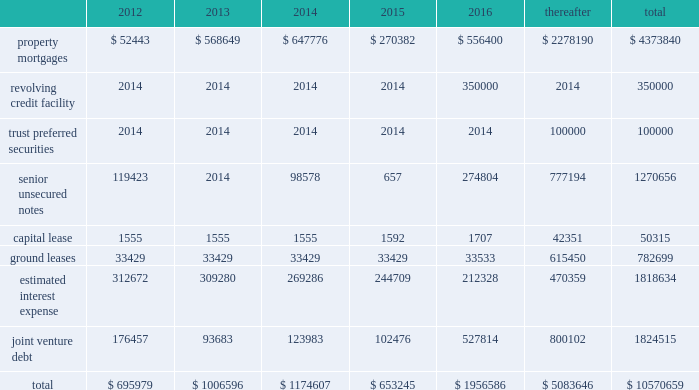56 / 57 management 2019s discussion and analysis of financial condition and results of operations junior subordinate deferrable interest debentures in june 2005 , we issued $ 100.0 a0million of trust preferred securities , which are reflected on the balance sheet as junior subordinate deferrable interest debentures .
The proceeds were used to repay our revolving credit facility .
The $ 100.0 a0million of junior subordi- nate deferrable interest debentures have a 30-year term ending july 2035 .
They bear interest at a fixed rate of 5.61% ( 5.61 % ) for the first 10 years ending july 2015 .
Thereafter , the rate will float at three month libor plus 1.25% ( 1.25 % ) .
The securities are redeemable at par .
Restrictive covenants the terms of the 2011 revolving credit facility and certain of our senior unsecured notes include certain restrictions and covenants which may limit , among other things , our ability to pay dividends ( as discussed below ) , make certain types of investments , incur additional indebtedness , incur liens and enter into negative pledge agreements and the disposition of assets , and which require compliance with financial ratios including our minimum tangible net worth , a maximum ratio of total indebtedness to total asset value , a minimum ratio of ebitda to fixed charges and a maximum ratio of unsecured indebtedness to unencumbered asset value .
The dividend restriction referred to above provides that we will not during any time when we are in default , make distributions with respect to common stock or other equity interests , except to enable us to continue to qualify as a reit for federal income tax purposes .
As of december a031 , 2011 and 2010 , we were in compli- ance with all such covenants .
Market rate risk we are exposed to changes in interest rates primarily from our floating rate borrowing arrangements .
We use interest rate deriv- ative instruments to manage exposure to interest rate changes .
A a0hypothetical 100 a0basis point increase in interest rates along the entire interest rate curve for 2011 and 2010 , would increase our annual interest cost by approximately $ 12.3 a0million and $ 11.0 a0mil- lion and would increase our share of joint venture annual interest cost by approximately $ 4.8 a0million and $ 6.7 a0million , respectively .
We recognize all derivatives on the balance sheet at fair value .
Derivatives that are not hedges must be adjusted to fair value through income .
If a derivative is a hedge , depending on the nature of the hedge , changes in the fair value of the derivative will either be offset against the change in fair value of the hedged asset , liability , or firm commitment through earnings , or recognized in other comprehensive income until the hedged item is recognized in earnings .
The ineffective portion of a derivative 2019s change in fair value is recognized immediately in earnings .
Approximately $ 4.8 a0billion of our long- term debt bore interest a0at fixed rates , and therefore the fair value of these instru- ments is affected by changes in the market interest rates .
The interest rate on our variable rate debt and joint venture debt as of december a031 , 2011 ranged from libor plus 150 a0basis points to libor plus 350 a0basis points .
Contractual obligations combined aggregate principal maturities of mortgages and other loans payable , our 2011 revolving credit facility , senior unsecured notes ( net of discount ) , trust preferred securities , our share of joint venture debt , including as- of-right extension options , estimated interest expense ( based on weighted average interest rates for the quarter ) , and our obligations under our capital lease and ground leases , as of december a031 , 2011 are as follows ( in thousands ) : .

In 2011 what was the percent of the capital lease that was due in 2013? 
Computations: (1555 / 50315)
Answer: 0.03091. 